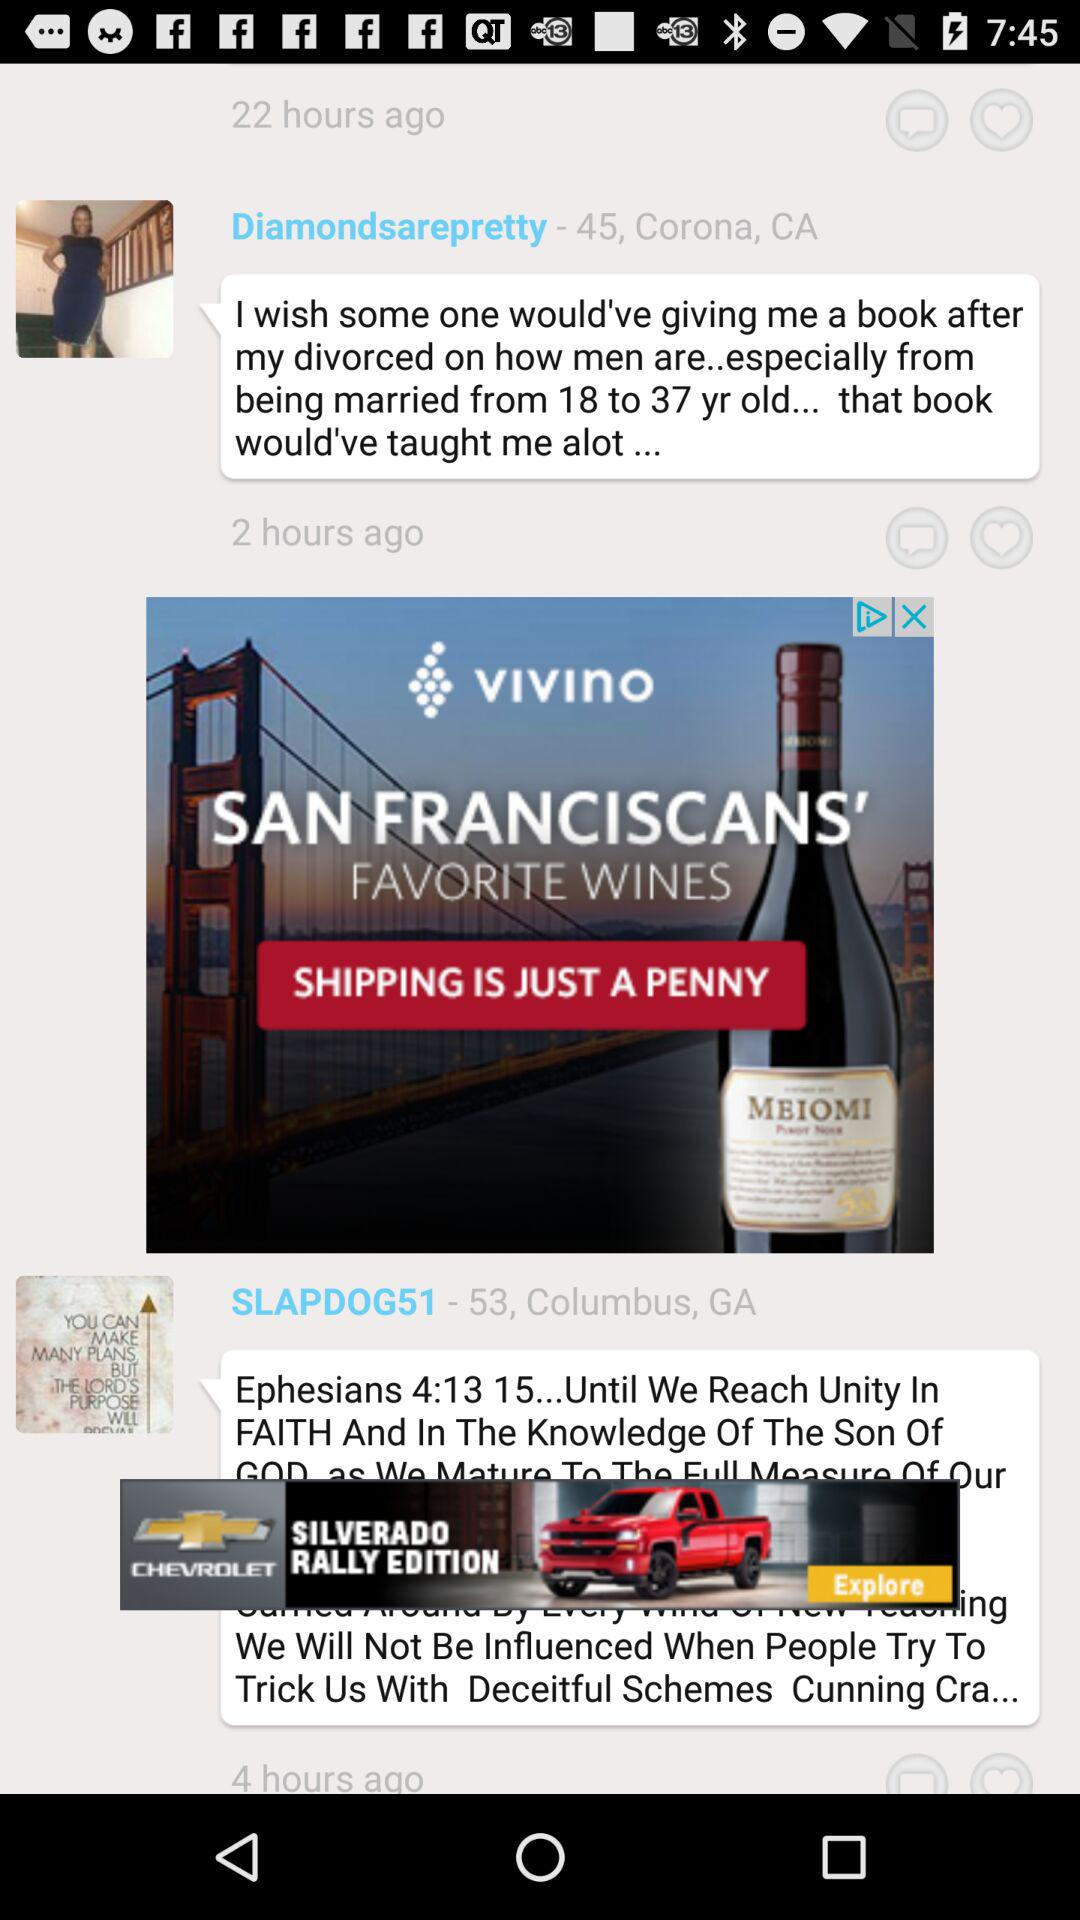How long ago did "SLAPDOG51" post? "SLAPDOG51" posted 4 hours ago. 